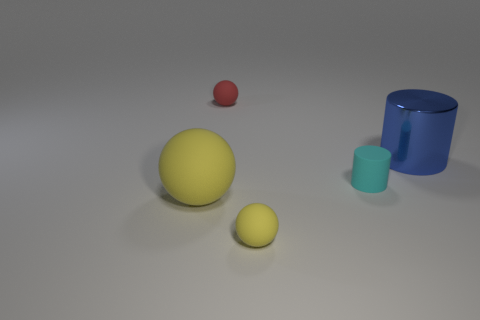How many small cylinders have the same color as the big metallic thing?
Ensure brevity in your answer.  0. There is a object that is the same color as the big sphere; what is it made of?
Keep it short and to the point. Rubber. What number of big objects are both in front of the big blue shiny object and to the right of the red rubber object?
Your response must be concise. 0. The large yellow sphere to the left of the yellow ball right of the large matte sphere is made of what material?
Keep it short and to the point. Rubber. Is there a cyan cylinder that has the same material as the blue cylinder?
Offer a very short reply. No. What is the material of the other yellow object that is the same size as the shiny thing?
Your answer should be compact. Rubber. How big is the yellow rubber thing in front of the yellow sphere that is left of the tiny object behind the rubber cylinder?
Offer a very short reply. Small. Are there any big yellow matte things in front of the sphere to the right of the red sphere?
Give a very brief answer. No. There is a large rubber thing; is it the same shape as the matte thing behind the metallic cylinder?
Keep it short and to the point. Yes. What is the color of the small matte thing that is to the right of the tiny yellow thing?
Offer a very short reply. Cyan. 